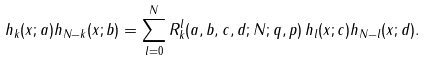<formula> <loc_0><loc_0><loc_500><loc_500>h _ { k } ( x ; a ) h _ { N - k } ( x ; b ) = \sum _ { l = 0 } ^ { N } R _ { k } ^ { l } ( a , b , c , d ; N ; q , p ) \, h _ { l } ( x ; c ) h _ { N - l } ( x ; d ) .</formula> 